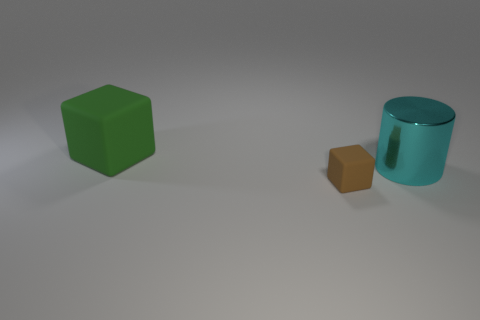What number of other large green objects are the same shape as the large green rubber thing?
Provide a succinct answer. 0. Are there the same number of large cyan things that are in front of the small brown rubber object and tiny brown matte objects that are on the right side of the big cube?
Offer a terse response. No. Are there any small gray cylinders?
Your response must be concise. No. How big is the green block behind the big cyan metallic cylinder right of the cube in front of the big green matte thing?
Keep it short and to the point. Large. What shape is the matte object that is the same size as the cyan cylinder?
Give a very brief answer. Cube. Are there any other things that have the same material as the big cyan cylinder?
Provide a short and direct response. No. What number of things are either matte cubes in front of the big cyan shiny cylinder or tiny gray rubber spheres?
Your answer should be very brief. 1. There is a tiny rubber thing that is in front of the matte thing to the left of the brown rubber block; are there any cubes that are to the left of it?
Give a very brief answer. Yes. How many gray balls are there?
Provide a succinct answer. 0. How many things are either rubber blocks behind the large cyan shiny cylinder or matte things behind the tiny matte object?
Ensure brevity in your answer.  1. 